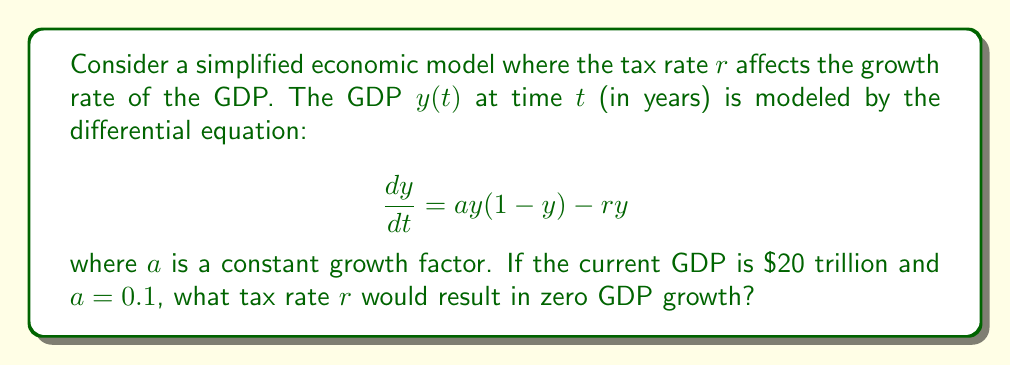Provide a solution to this math problem. To solve this problem, we'll follow these steps:

1) For zero GDP growth, we want $\frac{dy}{dt} = 0$. Let's set up the equation:

   $$0 = ay(1-y) - ry$$

2) We're given that the current GDP is $\$20$ trillion. Let's assume this is out of a potential maximum of $\$100$ trillion. So, $y = 0.2$.

3) Substitute the known values:

   $$0 = 0.1 \cdot 0.2(1-0.2) - 0.2r$$

4) Simplify:

   $$0 = 0.1 \cdot 0.2 \cdot 0.8 - 0.2r$$
   $$0 = 0.016 - 0.2r$$

5) Solve for $r$:

   $$0.2r = 0.016$$
   $$r = \frac{0.016}{0.2} = 0.08$$

6) Convert to a percentage:

   $$r = 8\%$$

This means a tax rate of 8% would result in zero GDP growth under this model.
Answer: 8% 